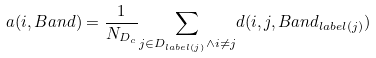Convert formula to latex. <formula><loc_0><loc_0><loc_500><loc_500>a ( i , B a n d ) = \frac { 1 } { N _ { D _ { c } } } \underset { j \in D _ { l a b e l ( j ) } \wedge i \neq j } { \sum } d ( i , j , B a n d _ { l a b e l ( j ) } )</formula> 